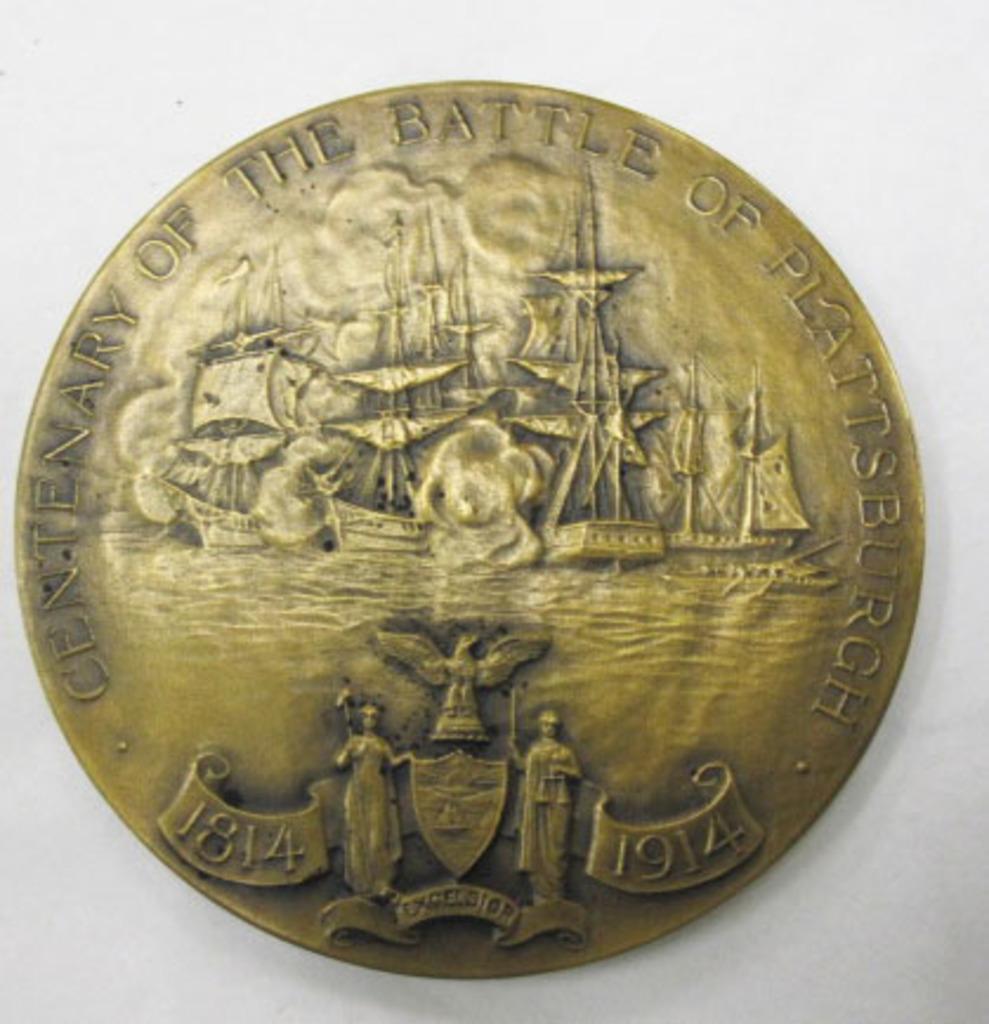How old is this coin?
Make the answer very short. 1914. 